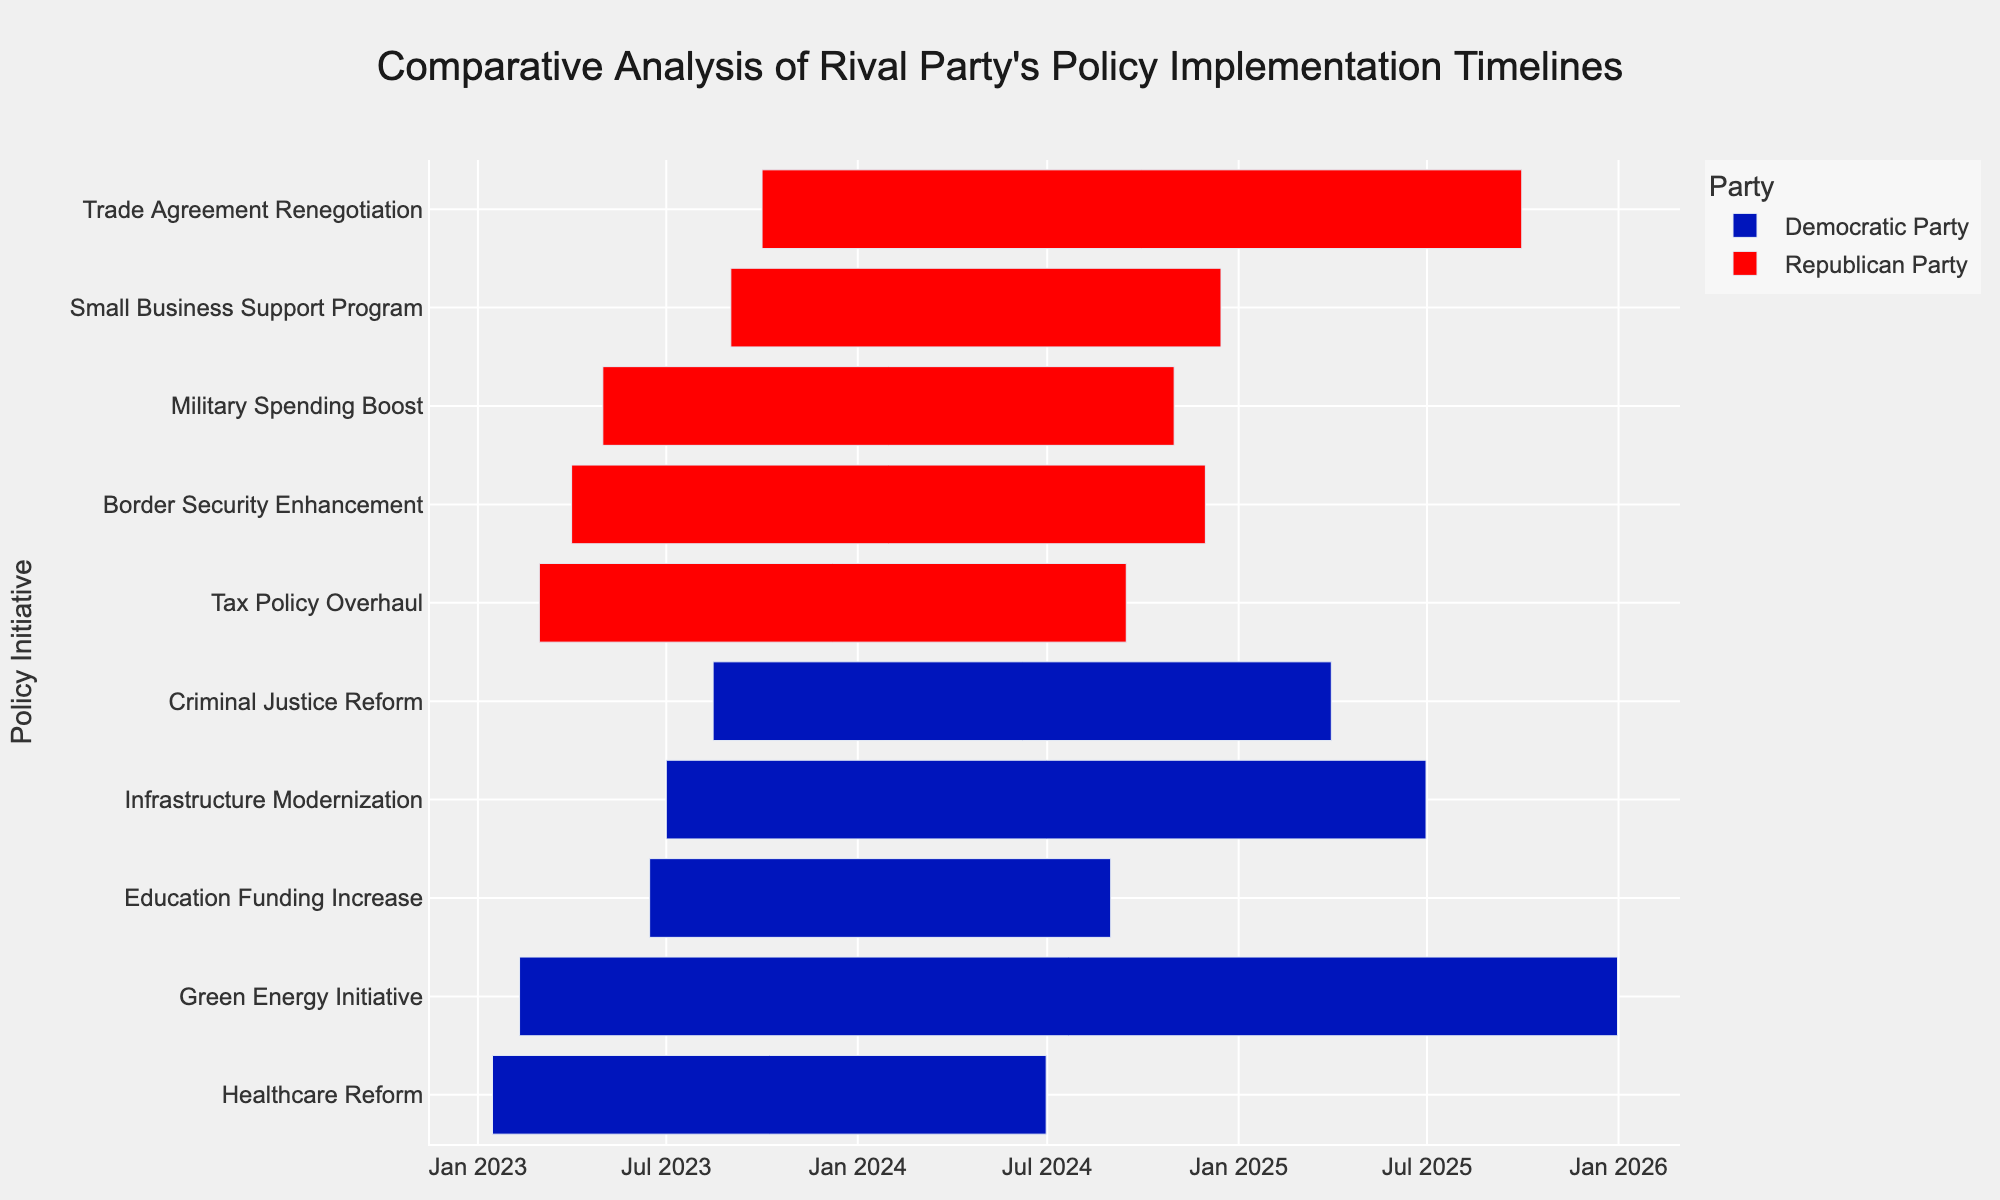What is the title of the chart? The title is typically displayed at the top of the chart. By looking at the top section, we can identify the text that represents it.
Answer: Comparative Analysis of Rival Party's Policy Implementation Timelines Which party has more policy initiatives shown in the chart? Count the number of tasks (policy initiatives) for each party.
Answer: Republican Party What time period does the 'Healthcare Reform' policy initiative by the Democratic Party cover? Refer to the horizontal bar representing 'Healthcare Reform' by the Democratic Party, checking its start and end dates.
Answer: January 15, 2023 to June 30, 2024 Which initiative starts first according to the chart? Look at the bars representing each initiative and identify the one with the earliest start date.
Answer: Healthcare Reform (Democratic Party) How long is the 'Green Energy Initiative' by the Democratic Party projected to last? Determine the difference between the start and end dates of the 'Green Energy Initiative'.
Answer: Almost 3 years Which party has the longest single policy initiative and what is it? Compare the durations of all policy initiatives for both parties to find the longest one.
Answer: Republican Party, Trade Agreement Renegotiation Did the Democratic Party or Republican Party's 'Education Funding Increase' end sooner? Check the end dates for both the Democratic Party's 'Education Funding Increase' and the nearest initiative from the Republican Party.
Answer: Democratic Party's 'Education Funding Increase' Between 'Tax Policy Overhaul' and 'Education Funding Increase', which policy completes first? Compare the end dates of the two mentioned initiatives.
Answer: Education Funding Increase What is the gap between the end of the 'Healthcare Reform' and the start of 'Small Business Support Program'? Calculate the time difference between the end date of 'Healthcare Reform' and the start date of 'Small Business Support Program'.
Answer: About 2 months Which party has overlapping timelines for their initiatives and which initiatives are they? Look at the horizontal bars to identify any overlap.
Answer: Democratic Party, Healthcare Reform and Green Energy Initiative 